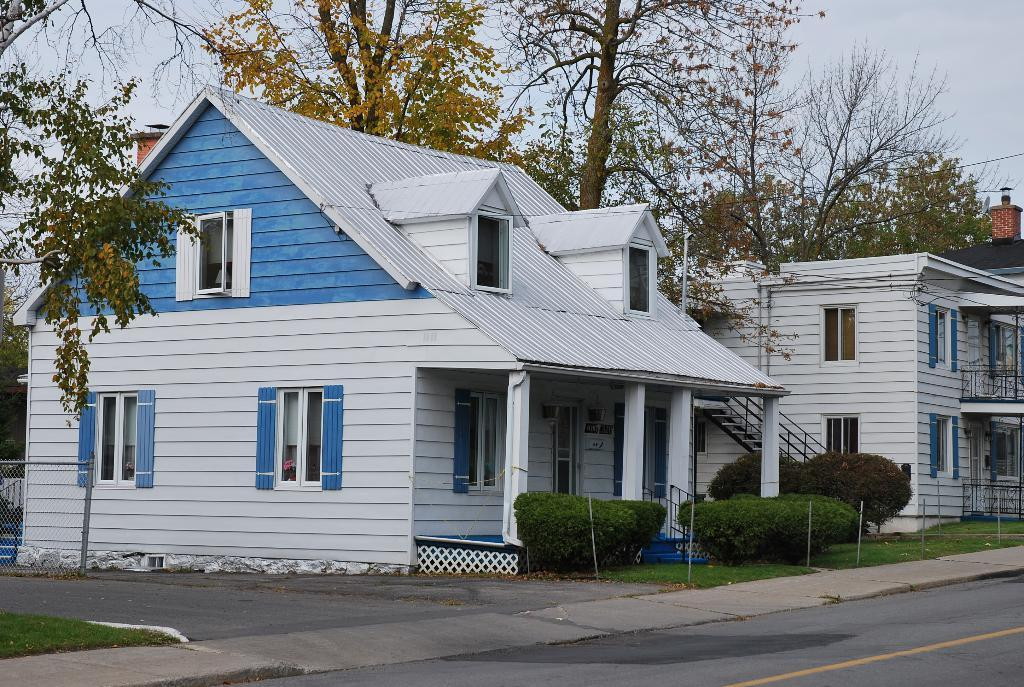What structures are located in the middle of the image? There are buildings in the middle of the image. What type of vegetation can be seen in the image? There are plants and trees in the image. What is visible at the top of the image? The sky is visible at the top of the image. What type of test can be seen being conducted in the image? There is no test or testing activity present in the image. What color is the thread used to decorate the plants in the image? There is no thread or decoration visible on the plants in the image. 